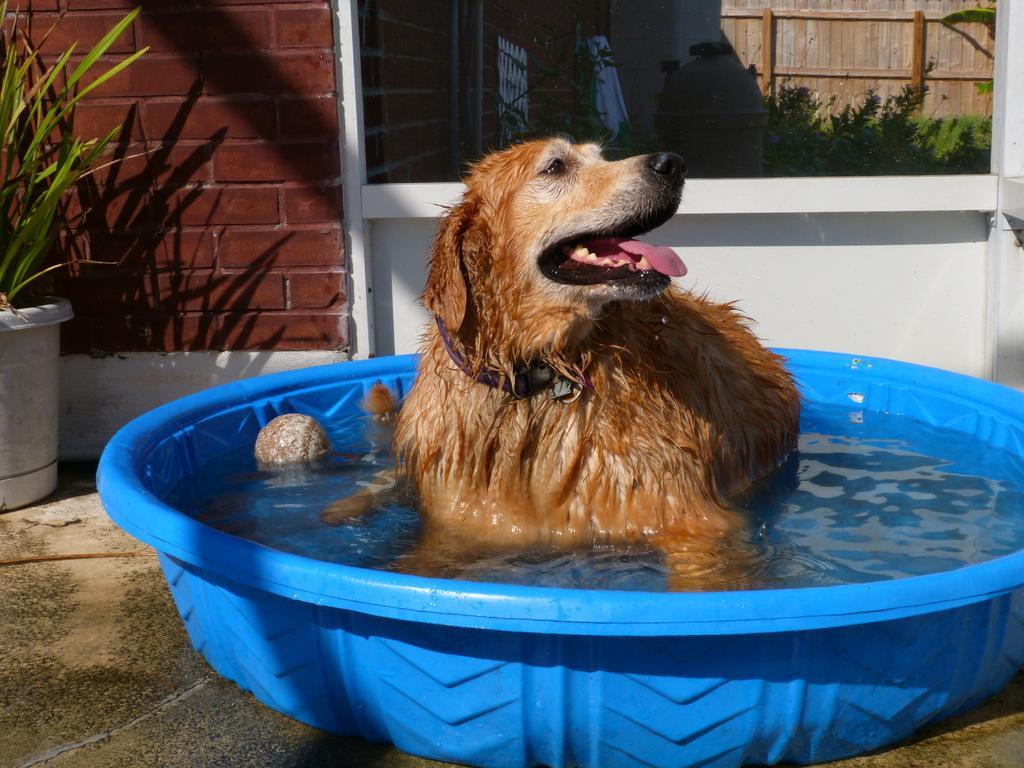How would you summarize this image in a sentence or two? There is a dog laying inside a bathtub,beside the dog there is a ball and behind the dog there is a wall and there is a plant kept in front of the wall,in the right side there is a mirror. 